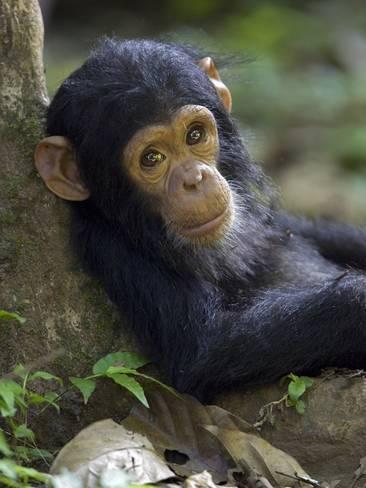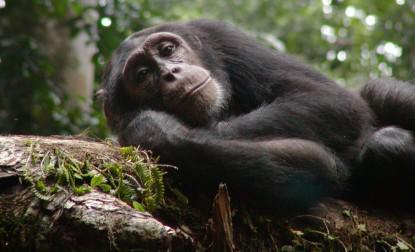The first image is the image on the left, the second image is the image on the right. For the images displayed, is the sentence "The left image features exactly one chimpanzee." factually correct? Answer yes or no. Yes. The first image is the image on the left, the second image is the image on the right. For the images displayed, is the sentence "The animal in the image on the left has its back to a tree." factually correct? Answer yes or no. Yes. 